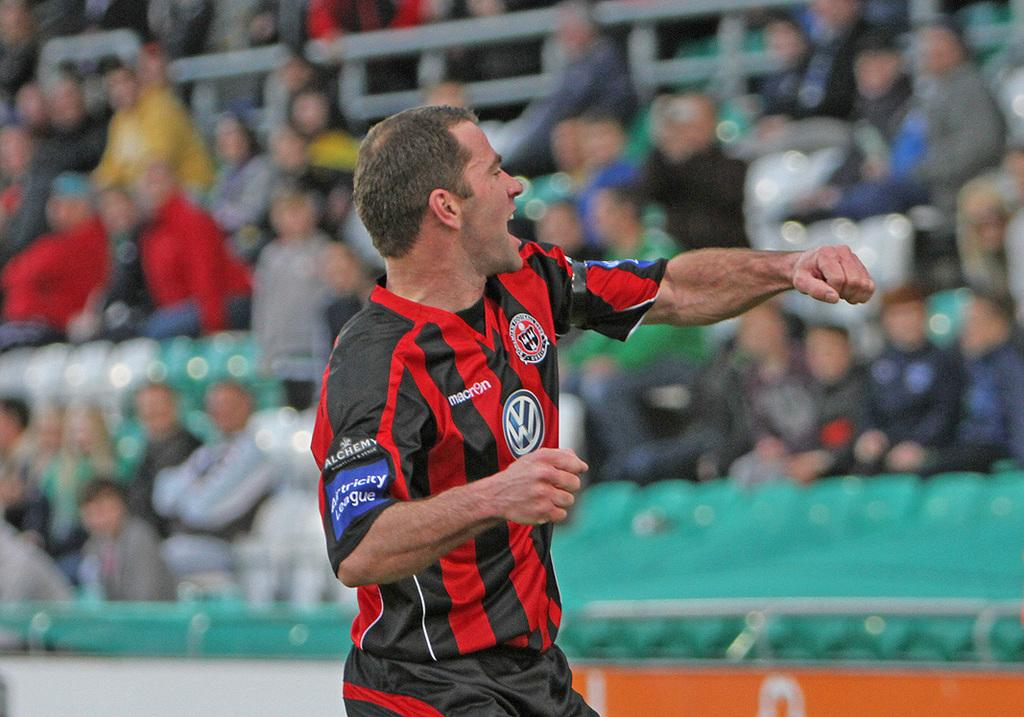<image>
Present a compact description of the photo's key features. A sports man in red and black, the word Alchemy is on his arm. 